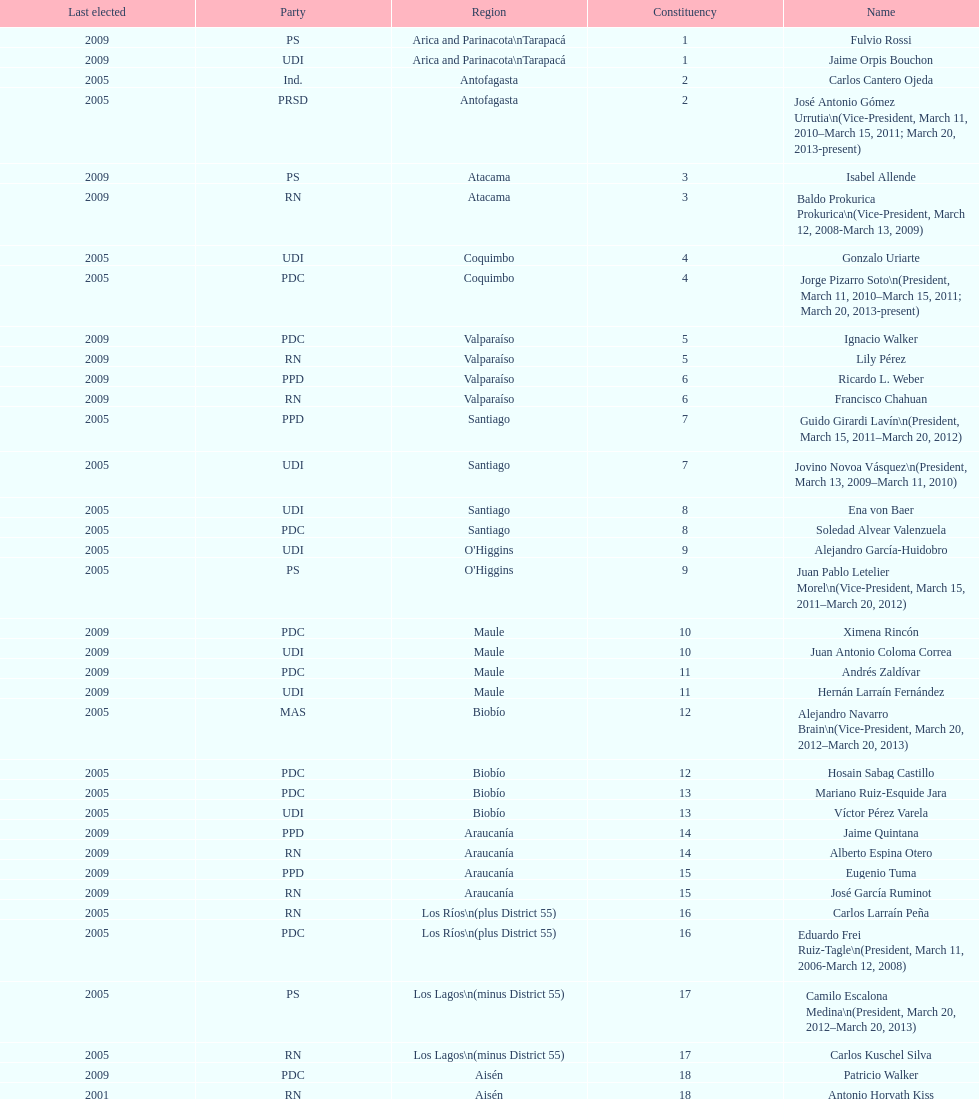What is the total number of constituencies? 19. 